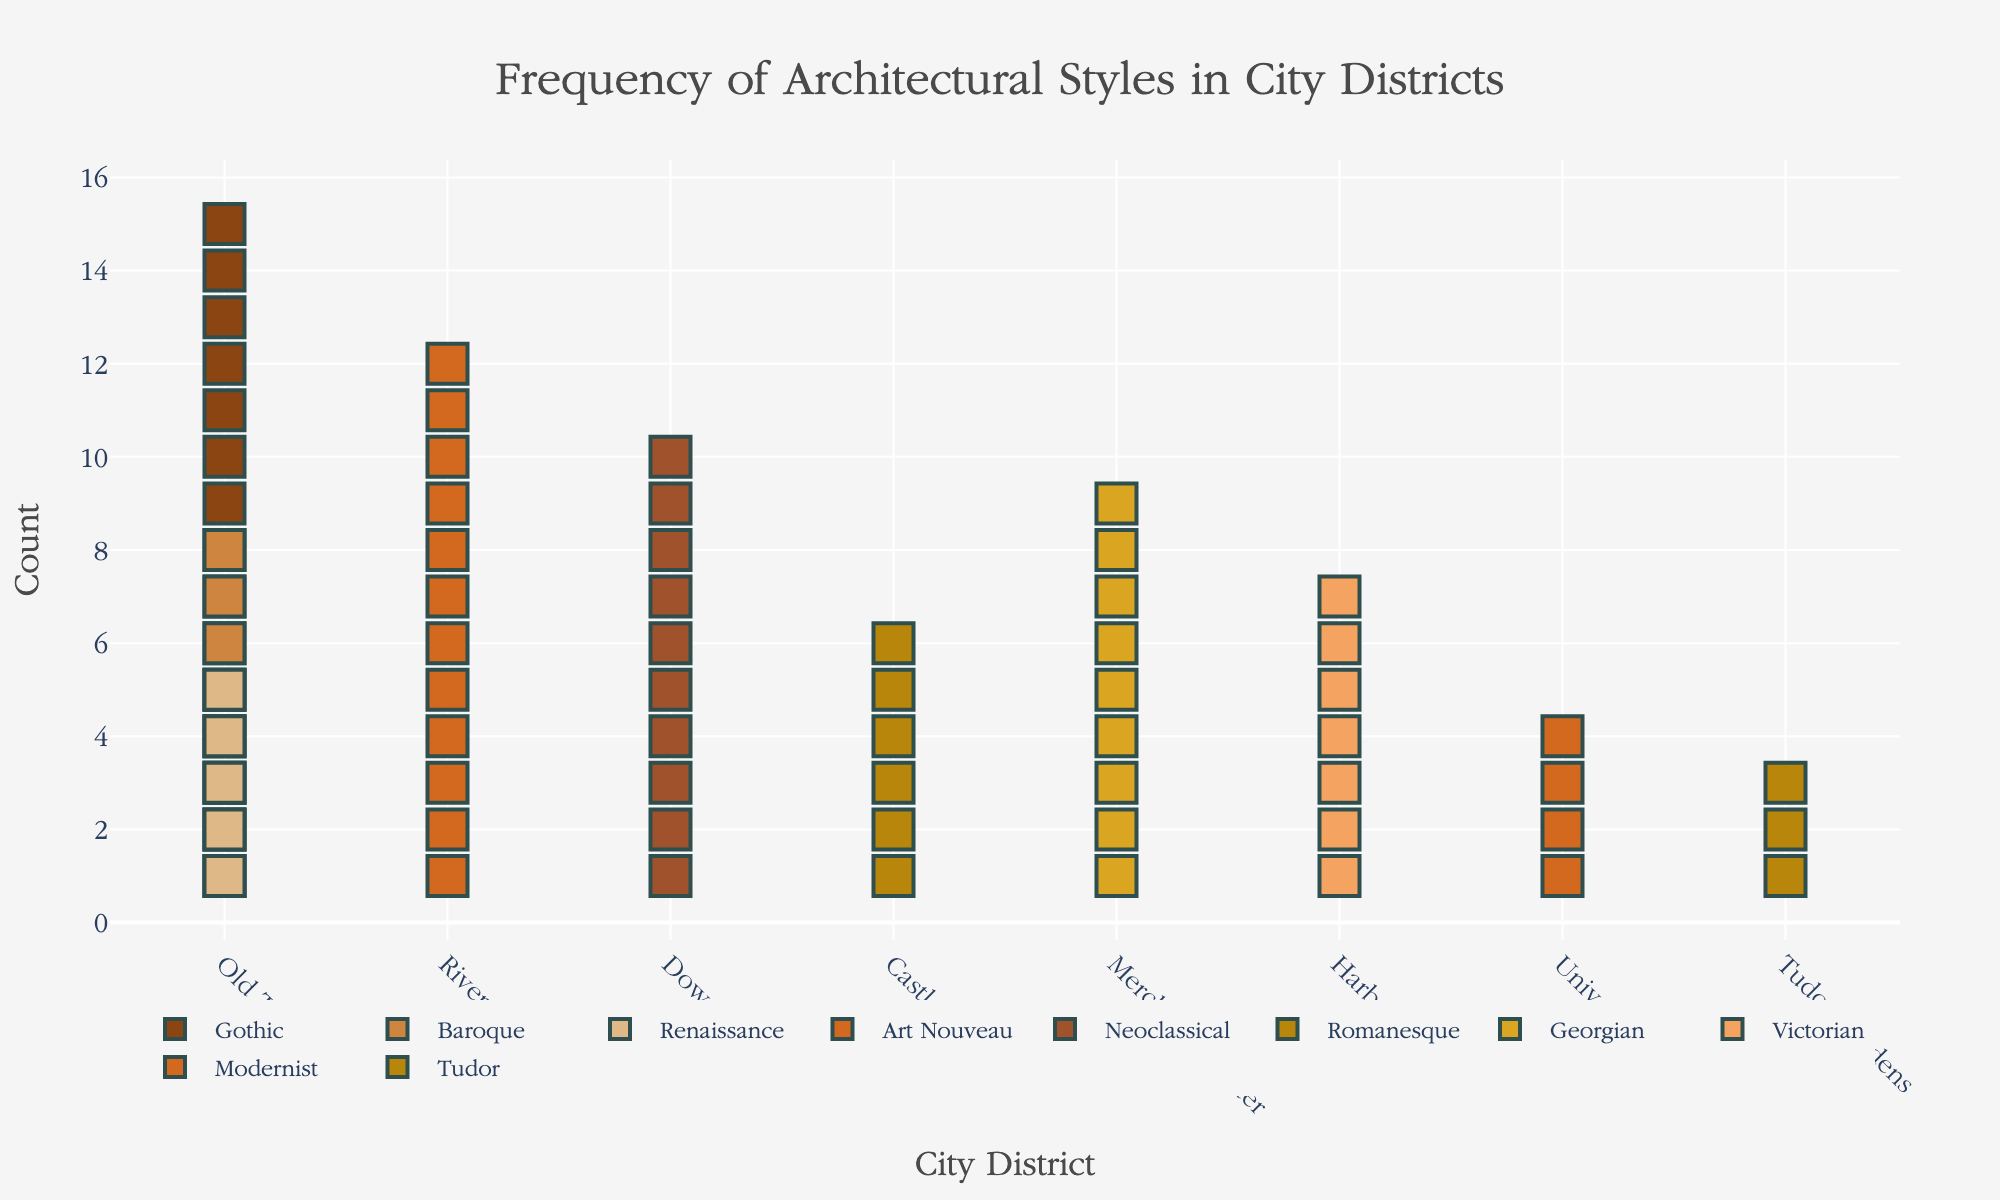what kind of architectural styles are found in the Old Town district? By observing the Isotype Plot, we can see that the markers corresponding to the Old Town district represent Gothic, Baroque, and Renaissance architectural styles.
Answer: Gothic, Baroque, Renaissance which city district has the highest count of preserved buildings in a single architectural style? To determine this, observe the heights of the columns in each city district. The Old Town district has the highest count with 15 Gothic buildings.
Answer: Old Town how many more preserved buildings are there of Gothic architectural style compared to Art Nouveau? Count the markers for both styles; Gothic has 15, and Art Nouveau has 12. Subtract 12 from 15.
Answer: 3 compare the number of buildings in Riverside to those in University Area. Which district has more and by how much? Riverside has 12 buildings and University Area has 4. Subtract 4 from 12.
Answer: Riverside by 8 how many total preserved buildings are there in the Old Town district? Add the counts of the Gothic, Baroque, and Renaissance styles in Old Town; 15 + 8 + 5 = 28.
Answer: 28 what is the combined number of Baroque and Neoclassical buildings? Baroque buildings are 8 and Neoclassical buildings are 10; add 8 and 10.
Answer: 18 which architectural style is specific to only one city district, and what district is it found in? Look at the styles and districts; only Tudor is found exclusively in the Tudor Gardens district.
Answer: Tudor, Tudor Gardens which district has the second fewest number of buildings, and how many are there? Excluding Tudor Gardens with 3 buildings, the district with the next fewest buildings is University Area with 4 buildings.
Answer: University Area, 4 if the styles Gothic and Baroque were to be combined into a single category, what would be the total count for the Old Town district in that new combined category? Sum the counts for Gothic and Baroque in Old Town: 15 (Gothic) + 8 (Baroque) = 23.
Answer: 23 